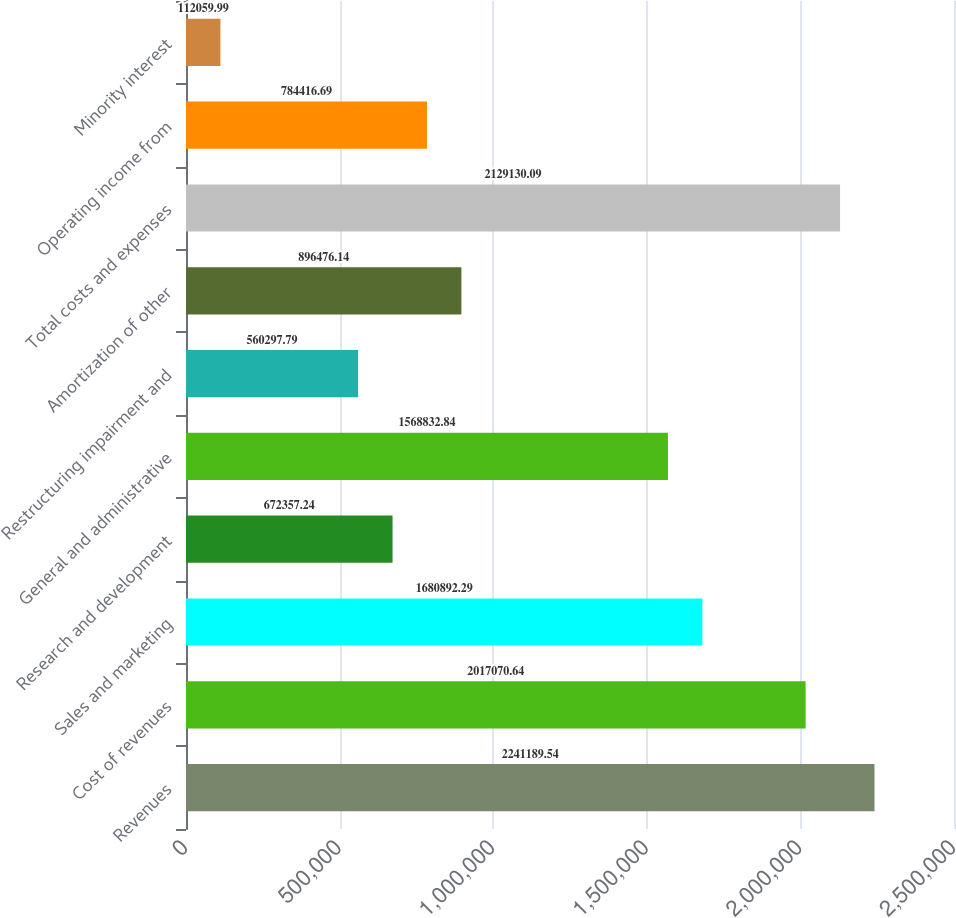Convert chart. <chart><loc_0><loc_0><loc_500><loc_500><bar_chart><fcel>Revenues<fcel>Cost of revenues<fcel>Sales and marketing<fcel>Research and development<fcel>General and administrative<fcel>Restructuring impairment and<fcel>Amortization of other<fcel>Total costs and expenses<fcel>Operating income from<fcel>Minority interest<nl><fcel>2.24119e+06<fcel>2.01707e+06<fcel>1.68089e+06<fcel>672357<fcel>1.56883e+06<fcel>560298<fcel>896476<fcel>2.12913e+06<fcel>784417<fcel>112060<nl></chart> 